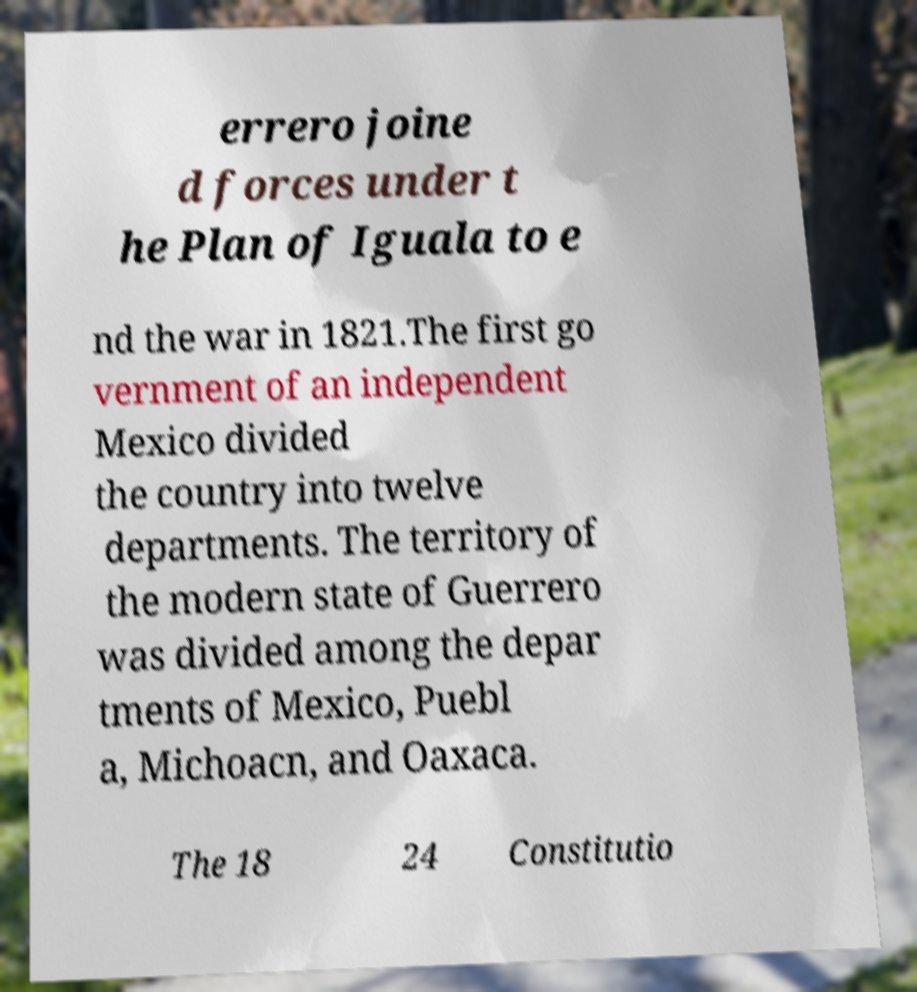Can you read and provide the text displayed in the image?This photo seems to have some interesting text. Can you extract and type it out for me? errero joine d forces under t he Plan of Iguala to e nd the war in 1821.The first go vernment of an independent Mexico divided the country into twelve departments. The territory of the modern state of Guerrero was divided among the depar tments of Mexico, Puebl a, Michoacn, and Oaxaca. The 18 24 Constitutio 